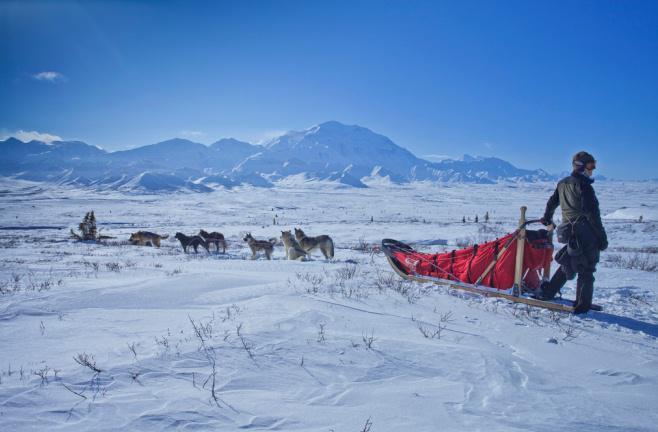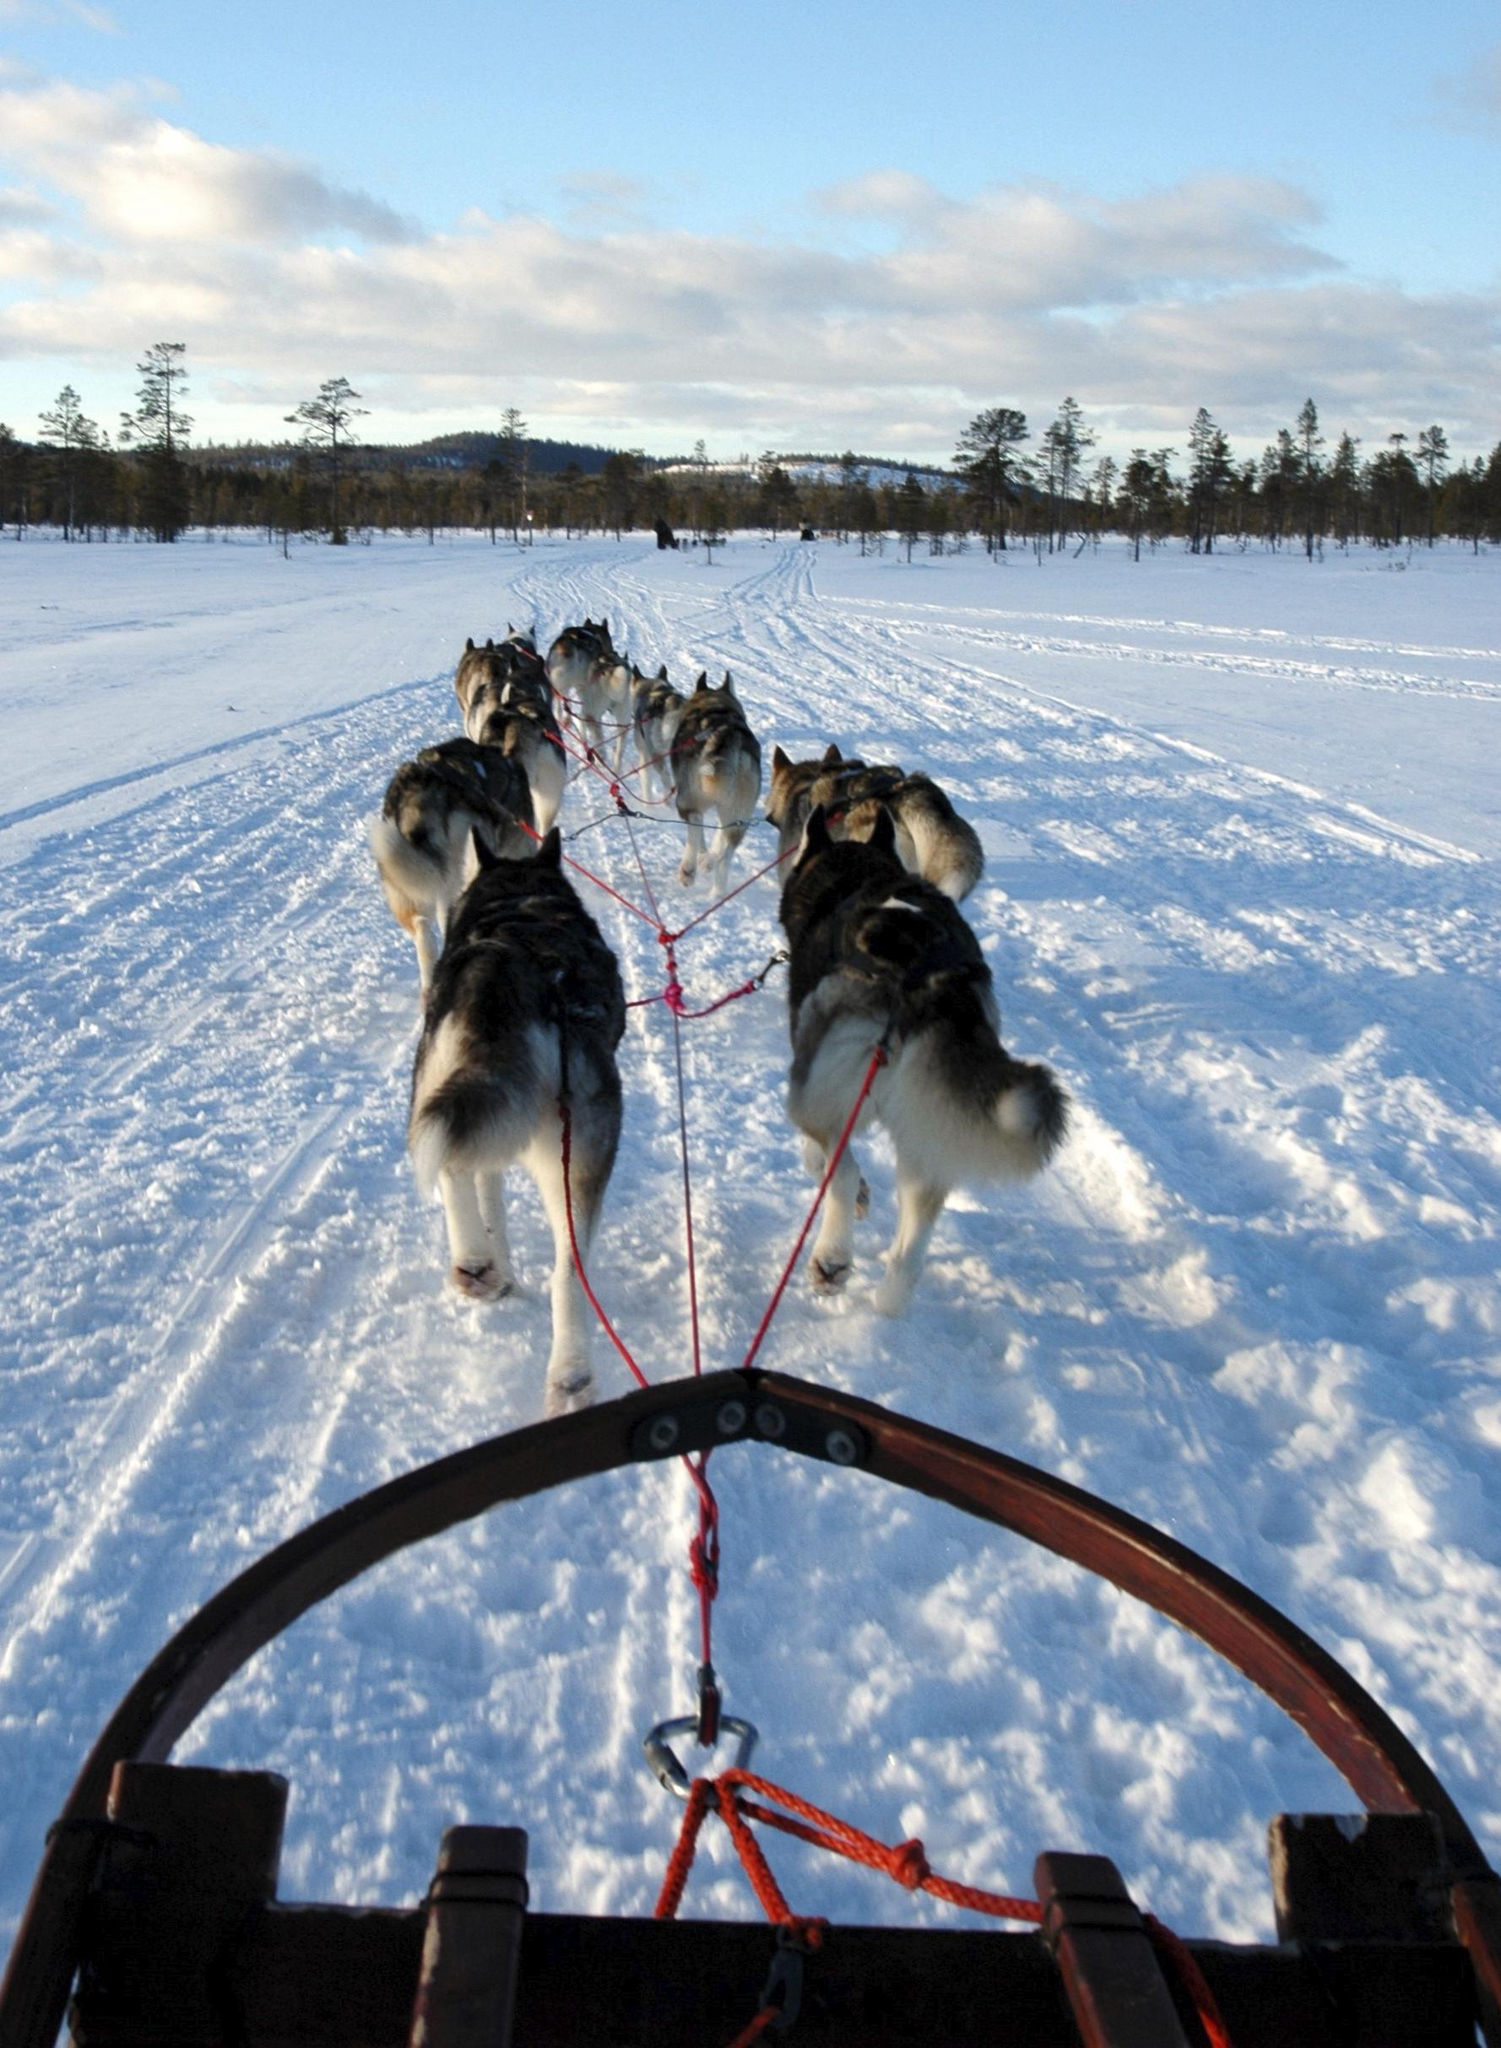The first image is the image on the left, the second image is the image on the right. Assess this claim about the two images: "One image shows a sled driver standing on the right, behind a red sled that's in profile, with a team of leftward-aimed dogs hitched to it.". Correct or not? Answer yes or no. Yes. The first image is the image on the left, the second image is the image on the right. Considering the images on both sides, is "There is exactly one sled driver visible." valid? Answer yes or no. Yes. 